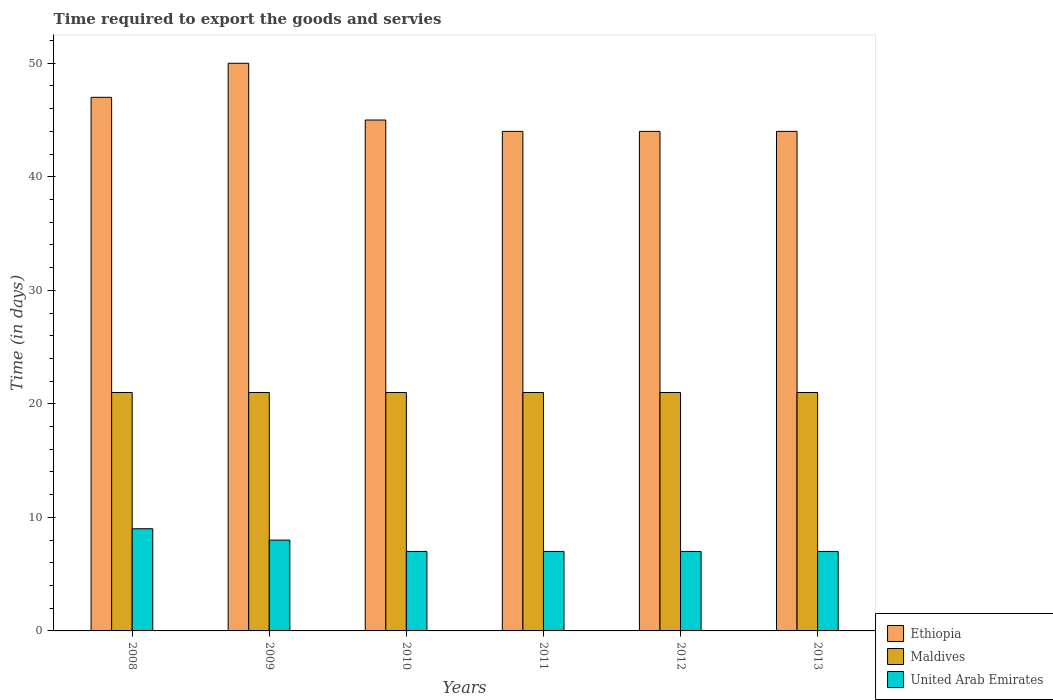What is the label of the 2nd group of bars from the left?
Your answer should be compact. 2009. What is the number of days required to export the goods and services in Maldives in 2009?
Keep it short and to the point. 21. Across all years, what is the maximum number of days required to export the goods and services in Maldives?
Give a very brief answer. 21. Across all years, what is the minimum number of days required to export the goods and services in Ethiopia?
Offer a terse response. 44. In which year was the number of days required to export the goods and services in Maldives minimum?
Your answer should be very brief. 2008. What is the total number of days required to export the goods and services in Maldives in the graph?
Provide a succinct answer. 126. What is the difference between the number of days required to export the goods and services in United Arab Emirates in 2009 and that in 2012?
Make the answer very short. 1. What is the difference between the number of days required to export the goods and services in Maldives in 2009 and the number of days required to export the goods and services in Ethiopia in 2013?
Offer a very short reply. -23. What is the average number of days required to export the goods and services in United Arab Emirates per year?
Your response must be concise. 7.5. In the year 2008, what is the difference between the number of days required to export the goods and services in United Arab Emirates and number of days required to export the goods and services in Ethiopia?
Your answer should be very brief. -38. What is the ratio of the number of days required to export the goods and services in Ethiopia in 2010 to that in 2012?
Ensure brevity in your answer.  1.02. Is the number of days required to export the goods and services in Maldives in 2009 less than that in 2013?
Keep it short and to the point. No. Is the difference between the number of days required to export the goods and services in United Arab Emirates in 2008 and 2012 greater than the difference between the number of days required to export the goods and services in Ethiopia in 2008 and 2012?
Your answer should be very brief. No. What is the difference between the highest and the second highest number of days required to export the goods and services in United Arab Emirates?
Keep it short and to the point. 1. What is the difference between the highest and the lowest number of days required to export the goods and services in United Arab Emirates?
Keep it short and to the point. 2. What does the 1st bar from the left in 2008 represents?
Ensure brevity in your answer.  Ethiopia. What does the 1st bar from the right in 2011 represents?
Offer a very short reply. United Arab Emirates. How many bars are there?
Give a very brief answer. 18. Are all the bars in the graph horizontal?
Ensure brevity in your answer.  No. How many years are there in the graph?
Give a very brief answer. 6. What is the difference between two consecutive major ticks on the Y-axis?
Offer a terse response. 10. Are the values on the major ticks of Y-axis written in scientific E-notation?
Provide a short and direct response. No. How many legend labels are there?
Give a very brief answer. 3. How are the legend labels stacked?
Offer a terse response. Vertical. What is the title of the graph?
Give a very brief answer. Time required to export the goods and servies. What is the label or title of the Y-axis?
Offer a very short reply. Time (in days). What is the Time (in days) of Ethiopia in 2008?
Your answer should be compact. 47. What is the Time (in days) of Maldives in 2009?
Offer a very short reply. 21. What is the Time (in days) in Ethiopia in 2010?
Offer a terse response. 45. What is the Time (in days) in United Arab Emirates in 2010?
Provide a succinct answer. 7. What is the Time (in days) of Ethiopia in 2011?
Provide a succinct answer. 44. What is the Time (in days) of Maldives in 2011?
Your answer should be very brief. 21. What is the Time (in days) in United Arab Emirates in 2011?
Ensure brevity in your answer.  7. What is the Time (in days) in Ethiopia in 2012?
Keep it short and to the point. 44. Across all years, what is the maximum Time (in days) of Ethiopia?
Provide a short and direct response. 50. Across all years, what is the maximum Time (in days) of United Arab Emirates?
Offer a terse response. 9. Across all years, what is the minimum Time (in days) in Ethiopia?
Provide a succinct answer. 44. What is the total Time (in days) of Ethiopia in the graph?
Your response must be concise. 274. What is the total Time (in days) in Maldives in the graph?
Your answer should be very brief. 126. What is the difference between the Time (in days) in Ethiopia in 2008 and that in 2009?
Provide a succinct answer. -3. What is the difference between the Time (in days) of Maldives in 2008 and that in 2010?
Your answer should be compact. 0. What is the difference between the Time (in days) of United Arab Emirates in 2008 and that in 2010?
Your response must be concise. 2. What is the difference between the Time (in days) of Ethiopia in 2008 and that in 2012?
Your response must be concise. 3. What is the difference between the Time (in days) in Ethiopia in 2008 and that in 2013?
Give a very brief answer. 3. What is the difference between the Time (in days) of Maldives in 2008 and that in 2013?
Your answer should be very brief. 0. What is the difference between the Time (in days) of United Arab Emirates in 2008 and that in 2013?
Offer a very short reply. 2. What is the difference between the Time (in days) of Ethiopia in 2009 and that in 2010?
Offer a very short reply. 5. What is the difference between the Time (in days) in Maldives in 2009 and that in 2010?
Keep it short and to the point. 0. What is the difference between the Time (in days) in Ethiopia in 2009 and that in 2011?
Offer a terse response. 6. What is the difference between the Time (in days) in Maldives in 2009 and that in 2011?
Keep it short and to the point. 0. What is the difference between the Time (in days) in United Arab Emirates in 2009 and that in 2011?
Provide a short and direct response. 1. What is the difference between the Time (in days) in Maldives in 2009 and that in 2012?
Offer a terse response. 0. What is the difference between the Time (in days) of Maldives in 2009 and that in 2013?
Keep it short and to the point. 0. What is the difference between the Time (in days) of Ethiopia in 2010 and that in 2011?
Your answer should be compact. 1. What is the difference between the Time (in days) in United Arab Emirates in 2010 and that in 2011?
Provide a short and direct response. 0. What is the difference between the Time (in days) of Maldives in 2010 and that in 2012?
Provide a succinct answer. 0. What is the difference between the Time (in days) of Ethiopia in 2011 and that in 2012?
Provide a succinct answer. 0. What is the difference between the Time (in days) in Maldives in 2011 and that in 2012?
Make the answer very short. 0. What is the difference between the Time (in days) of Ethiopia in 2011 and that in 2013?
Offer a terse response. 0. What is the difference between the Time (in days) in Maldives in 2011 and that in 2013?
Provide a succinct answer. 0. What is the difference between the Time (in days) of United Arab Emirates in 2011 and that in 2013?
Provide a short and direct response. 0. What is the difference between the Time (in days) of Ethiopia in 2008 and the Time (in days) of Maldives in 2009?
Ensure brevity in your answer.  26. What is the difference between the Time (in days) in Ethiopia in 2008 and the Time (in days) in United Arab Emirates in 2009?
Give a very brief answer. 39. What is the difference between the Time (in days) in Maldives in 2008 and the Time (in days) in United Arab Emirates in 2009?
Provide a short and direct response. 13. What is the difference between the Time (in days) of Ethiopia in 2008 and the Time (in days) of Maldives in 2010?
Your answer should be very brief. 26. What is the difference between the Time (in days) of Ethiopia in 2008 and the Time (in days) of United Arab Emirates in 2011?
Give a very brief answer. 40. What is the difference between the Time (in days) in Ethiopia in 2008 and the Time (in days) in Maldives in 2012?
Ensure brevity in your answer.  26. What is the difference between the Time (in days) of Ethiopia in 2008 and the Time (in days) of United Arab Emirates in 2012?
Offer a terse response. 40. What is the difference between the Time (in days) of Ethiopia in 2008 and the Time (in days) of Maldives in 2013?
Your response must be concise. 26. What is the difference between the Time (in days) of Ethiopia in 2008 and the Time (in days) of United Arab Emirates in 2013?
Make the answer very short. 40. What is the difference between the Time (in days) of Ethiopia in 2009 and the Time (in days) of United Arab Emirates in 2010?
Offer a terse response. 43. What is the difference between the Time (in days) in Ethiopia in 2009 and the Time (in days) in Maldives in 2011?
Your response must be concise. 29. What is the difference between the Time (in days) in Ethiopia in 2009 and the Time (in days) in United Arab Emirates in 2011?
Provide a succinct answer. 43. What is the difference between the Time (in days) of Maldives in 2009 and the Time (in days) of United Arab Emirates in 2011?
Keep it short and to the point. 14. What is the difference between the Time (in days) in Ethiopia in 2009 and the Time (in days) in United Arab Emirates in 2012?
Give a very brief answer. 43. What is the difference between the Time (in days) in Maldives in 2009 and the Time (in days) in United Arab Emirates in 2012?
Provide a succinct answer. 14. What is the difference between the Time (in days) of Maldives in 2009 and the Time (in days) of United Arab Emirates in 2013?
Give a very brief answer. 14. What is the difference between the Time (in days) in Ethiopia in 2010 and the Time (in days) in Maldives in 2011?
Provide a succinct answer. 24. What is the difference between the Time (in days) of Ethiopia in 2010 and the Time (in days) of United Arab Emirates in 2011?
Make the answer very short. 38. What is the difference between the Time (in days) in Maldives in 2010 and the Time (in days) in United Arab Emirates in 2011?
Provide a succinct answer. 14. What is the difference between the Time (in days) of Maldives in 2010 and the Time (in days) of United Arab Emirates in 2012?
Your response must be concise. 14. What is the difference between the Time (in days) of Ethiopia in 2011 and the Time (in days) of Maldives in 2013?
Your response must be concise. 23. What is the difference between the Time (in days) in Ethiopia in 2012 and the Time (in days) in Maldives in 2013?
Ensure brevity in your answer.  23. What is the difference between the Time (in days) in Ethiopia in 2012 and the Time (in days) in United Arab Emirates in 2013?
Keep it short and to the point. 37. What is the difference between the Time (in days) of Maldives in 2012 and the Time (in days) of United Arab Emirates in 2013?
Give a very brief answer. 14. What is the average Time (in days) in Ethiopia per year?
Keep it short and to the point. 45.67. What is the average Time (in days) of Maldives per year?
Keep it short and to the point. 21. In the year 2008, what is the difference between the Time (in days) in Ethiopia and Time (in days) in Maldives?
Make the answer very short. 26. In the year 2008, what is the difference between the Time (in days) of Ethiopia and Time (in days) of United Arab Emirates?
Provide a short and direct response. 38. In the year 2009, what is the difference between the Time (in days) of Ethiopia and Time (in days) of United Arab Emirates?
Make the answer very short. 42. In the year 2009, what is the difference between the Time (in days) of Maldives and Time (in days) of United Arab Emirates?
Your answer should be very brief. 13. In the year 2010, what is the difference between the Time (in days) of Ethiopia and Time (in days) of Maldives?
Your answer should be very brief. 24. In the year 2010, what is the difference between the Time (in days) of Ethiopia and Time (in days) of United Arab Emirates?
Ensure brevity in your answer.  38. In the year 2010, what is the difference between the Time (in days) in Maldives and Time (in days) in United Arab Emirates?
Ensure brevity in your answer.  14. In the year 2011, what is the difference between the Time (in days) in Ethiopia and Time (in days) in Maldives?
Provide a succinct answer. 23. In the year 2011, what is the difference between the Time (in days) in Ethiopia and Time (in days) in United Arab Emirates?
Make the answer very short. 37. In the year 2012, what is the difference between the Time (in days) in Ethiopia and Time (in days) in United Arab Emirates?
Give a very brief answer. 37. In the year 2012, what is the difference between the Time (in days) of Maldives and Time (in days) of United Arab Emirates?
Ensure brevity in your answer.  14. In the year 2013, what is the difference between the Time (in days) in Ethiopia and Time (in days) in United Arab Emirates?
Ensure brevity in your answer.  37. What is the ratio of the Time (in days) of Ethiopia in 2008 to that in 2009?
Your answer should be compact. 0.94. What is the ratio of the Time (in days) of Maldives in 2008 to that in 2009?
Ensure brevity in your answer.  1. What is the ratio of the Time (in days) of Ethiopia in 2008 to that in 2010?
Keep it short and to the point. 1.04. What is the ratio of the Time (in days) in Maldives in 2008 to that in 2010?
Give a very brief answer. 1. What is the ratio of the Time (in days) in Ethiopia in 2008 to that in 2011?
Your answer should be compact. 1.07. What is the ratio of the Time (in days) of United Arab Emirates in 2008 to that in 2011?
Offer a terse response. 1.29. What is the ratio of the Time (in days) in Ethiopia in 2008 to that in 2012?
Make the answer very short. 1.07. What is the ratio of the Time (in days) of Ethiopia in 2008 to that in 2013?
Offer a very short reply. 1.07. What is the ratio of the Time (in days) in Maldives in 2009 to that in 2010?
Provide a short and direct response. 1. What is the ratio of the Time (in days) in United Arab Emirates in 2009 to that in 2010?
Make the answer very short. 1.14. What is the ratio of the Time (in days) of Ethiopia in 2009 to that in 2011?
Offer a terse response. 1.14. What is the ratio of the Time (in days) of Maldives in 2009 to that in 2011?
Make the answer very short. 1. What is the ratio of the Time (in days) of United Arab Emirates in 2009 to that in 2011?
Offer a very short reply. 1.14. What is the ratio of the Time (in days) of Ethiopia in 2009 to that in 2012?
Ensure brevity in your answer.  1.14. What is the ratio of the Time (in days) of Ethiopia in 2009 to that in 2013?
Your response must be concise. 1.14. What is the ratio of the Time (in days) of United Arab Emirates in 2009 to that in 2013?
Provide a short and direct response. 1.14. What is the ratio of the Time (in days) in Ethiopia in 2010 to that in 2011?
Your answer should be very brief. 1.02. What is the ratio of the Time (in days) of United Arab Emirates in 2010 to that in 2011?
Provide a short and direct response. 1. What is the ratio of the Time (in days) in Ethiopia in 2010 to that in 2012?
Give a very brief answer. 1.02. What is the ratio of the Time (in days) of Ethiopia in 2010 to that in 2013?
Make the answer very short. 1.02. What is the ratio of the Time (in days) in United Arab Emirates in 2011 to that in 2013?
Offer a very short reply. 1. What is the ratio of the Time (in days) of Ethiopia in 2012 to that in 2013?
Keep it short and to the point. 1. What is the ratio of the Time (in days) of Maldives in 2012 to that in 2013?
Keep it short and to the point. 1. What is the ratio of the Time (in days) in United Arab Emirates in 2012 to that in 2013?
Offer a very short reply. 1. What is the difference between the highest and the second highest Time (in days) in Ethiopia?
Give a very brief answer. 3. What is the difference between the highest and the second highest Time (in days) in Maldives?
Ensure brevity in your answer.  0. What is the difference between the highest and the second highest Time (in days) of United Arab Emirates?
Provide a short and direct response. 1. What is the difference between the highest and the lowest Time (in days) of Maldives?
Your response must be concise. 0. 